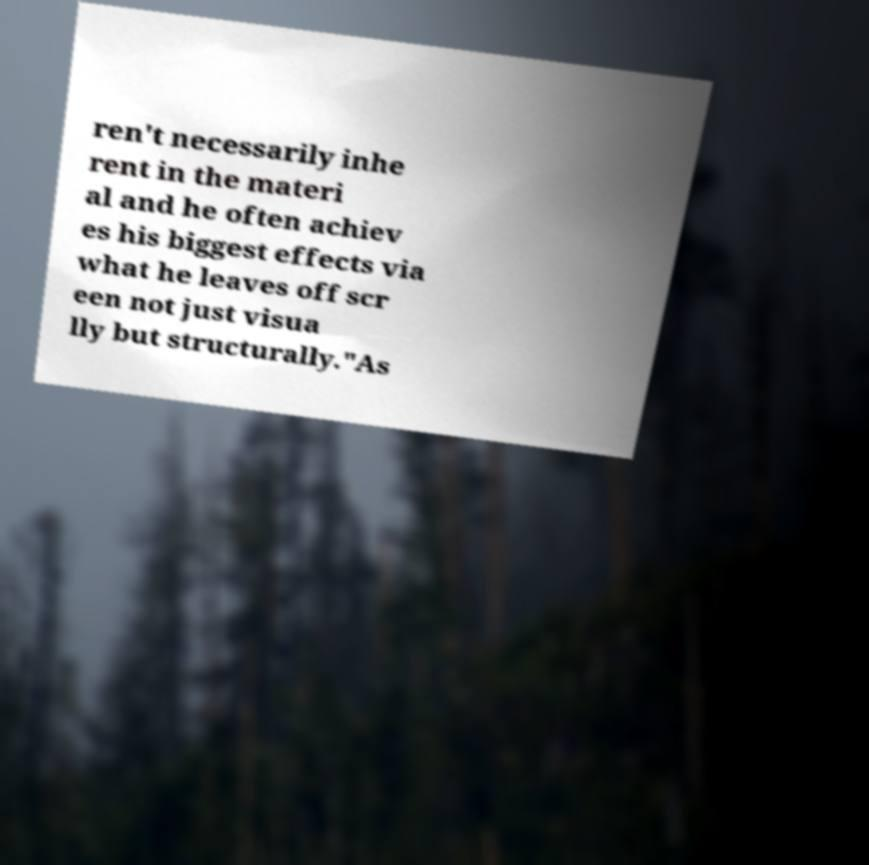I need the written content from this picture converted into text. Can you do that? ren't necessarily inhe rent in the materi al and he often achiev es his biggest effects via what he leaves off scr een not just visua lly but structurally."As 